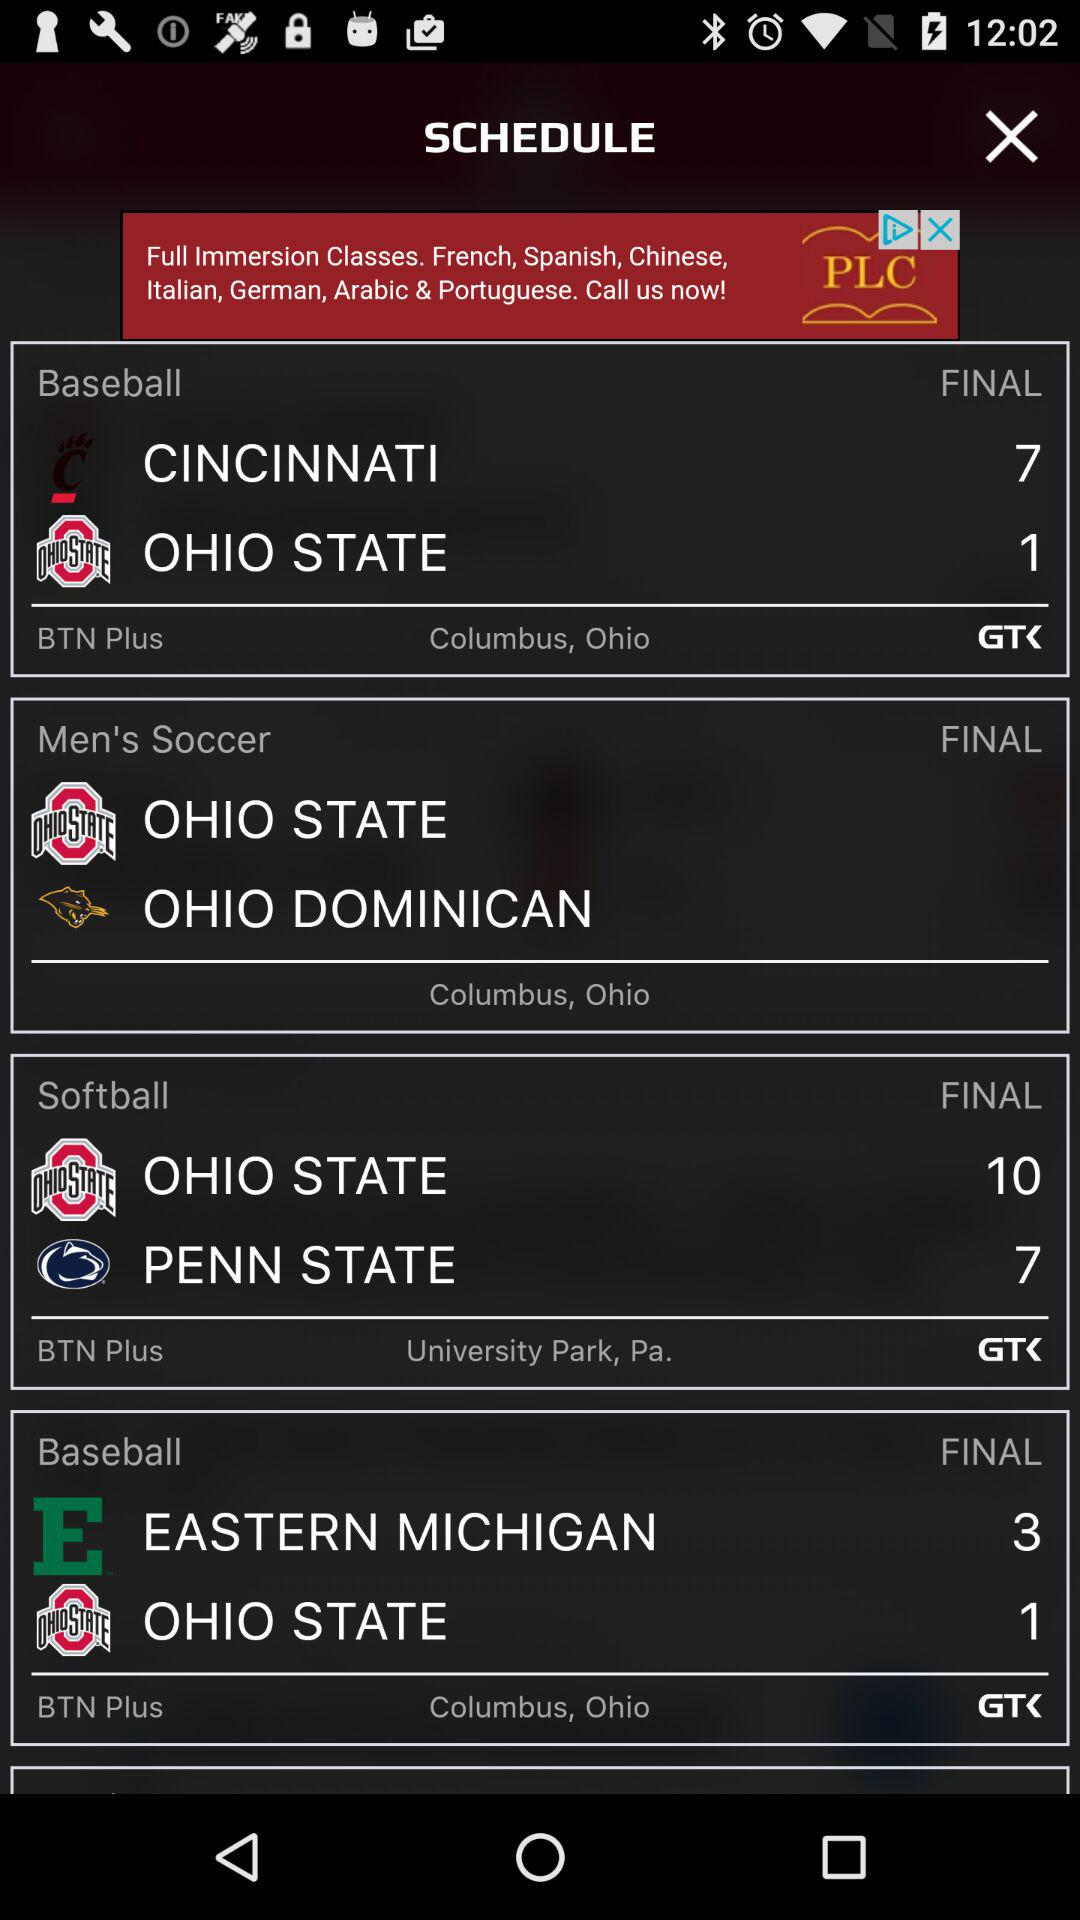Which team has played the most games, based on the number of times their logo appears?
Answer the question using a single word or phrase. Ohio State 